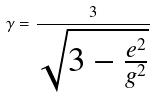<formula> <loc_0><loc_0><loc_500><loc_500>\gamma = \frac { 3 } { \sqrt { 3 - \frac { e ^ { 2 } } { g ^ { 2 } } } }</formula> 